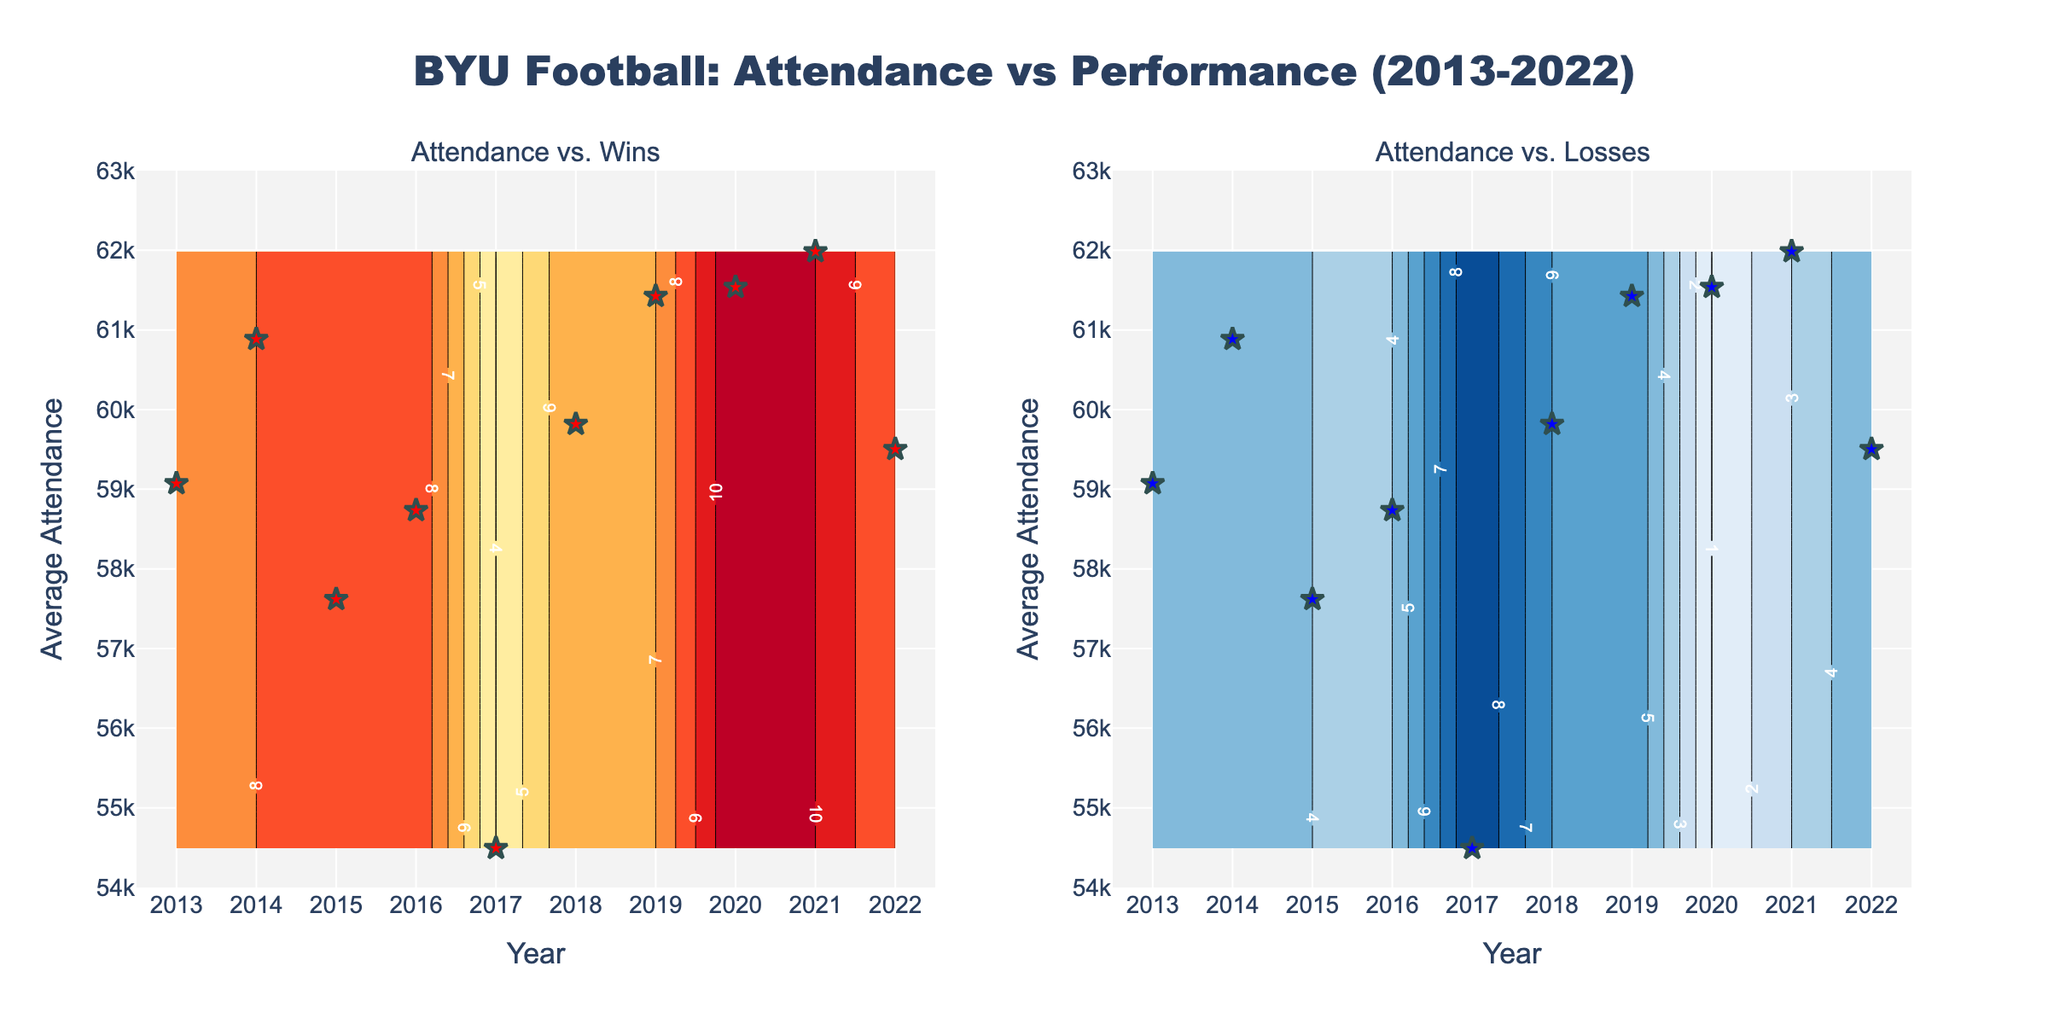What is the title of the plot? The title is located at the top of the plot and reads "BYU Football: Attendance vs Performance (2013-2022)."
Answer: BYU Football: Attendance vs Performance (2013-2022) What does the Y-axis represent in the two subplots? The Y-axis in both subplots is labeled "Average Attendance," indicating it represents the average number of people attending the games in a given year.
Answer: Average Attendance How are winning percentages visualized in the first subplot? The Contour plot on the left subplot uses colors from the 'YlOrRd' scale to show winning percentages, with contours indicating different levels.
Answer: As contour levels using 'YlOrRd' color scale What is the highest attendance observed and in which year? Looking at the scattered star points on both plots, the highest attendance is a red/blue star seen at the year 2021, with attendance around 62,000.
Answer: 61985 in 2021 How do the attendance patterns correlate with the loss count over the years? By observing the right subplot, we can infer that higher attendance tends to occur when the loss count is lower, illustrated by the 'Blues' scale which shows higher density of lower loss numbers at higher attendance values.
Answer: Higher attendance correlates with lower loss count Which year had the lowest average attendance, and what was the record that year? The year 2017 shows the lowest average attendance around 54,492, and the win/loss record that year was 4 wins and 9 losses, as indicated by the scattered star point on both plots.
Answer: 2017 with 4 wins and 9 losses What trend do you see in attendance versus win count around 2020? The left subplot shows a red star indicating high attendance around 2020, which is surrounded by high win count contours, suggesting a positive correlation between higher attendance and win count during that period.
Answer: Higher attendance with higher win count in 2020 In years where attendance exceeded 60,000, how many losses were typical? Observing the right subplot, the blue stars at attendance levels above 60,000 align with contours showing lower loss counts, typically around 1 to 3 losses.
Answer: Typically 1 to 3 losses How does the contour plot for losses compare to the contour plot for wins in terms of attendance impact? Comparing the two subplots, it appears that high wins (left plot) are associated with rising attendance, whereas high losses (right plot) are associated with dipping attendance, showing an inverse relationship.
Answer: Wins drive attendance up, losses drive attendance down 